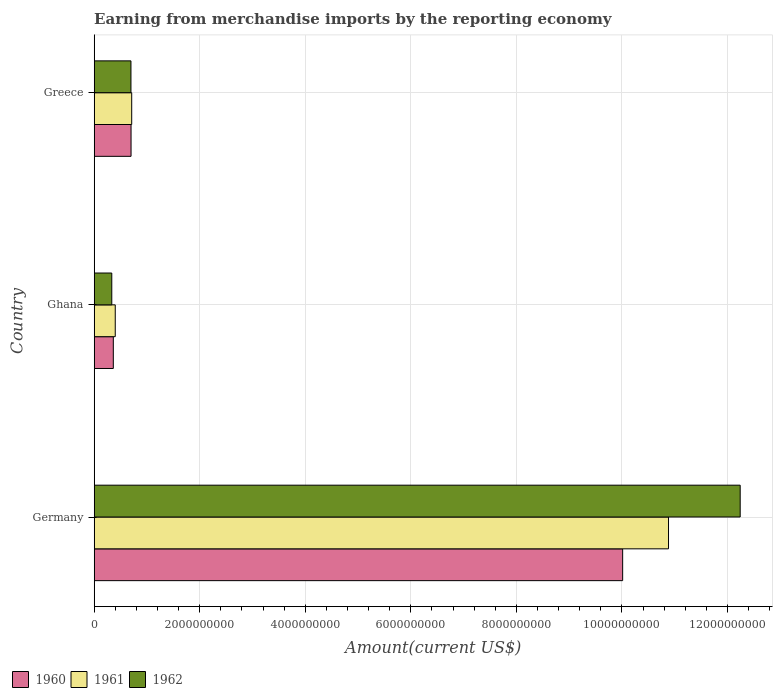How many different coloured bars are there?
Provide a succinct answer. 3. How many groups of bars are there?
Offer a very short reply. 3. Are the number of bars per tick equal to the number of legend labels?
Your answer should be compact. Yes. What is the label of the 1st group of bars from the top?
Ensure brevity in your answer.  Greece. In how many cases, is the number of bars for a given country not equal to the number of legend labels?
Provide a succinct answer. 0. What is the amount earned from merchandise imports in 1962 in Greece?
Give a very brief answer. 6.96e+08. Across all countries, what is the maximum amount earned from merchandise imports in 1960?
Make the answer very short. 1.00e+1. Across all countries, what is the minimum amount earned from merchandise imports in 1962?
Your response must be concise. 3.33e+08. In which country was the amount earned from merchandise imports in 1962 maximum?
Your answer should be very brief. Germany. What is the total amount earned from merchandise imports in 1962 in the graph?
Keep it short and to the point. 1.33e+1. What is the difference between the amount earned from merchandise imports in 1961 in Germany and that in Ghana?
Offer a very short reply. 1.05e+1. What is the difference between the amount earned from merchandise imports in 1960 in Greece and the amount earned from merchandise imports in 1962 in Ghana?
Ensure brevity in your answer.  3.65e+08. What is the average amount earned from merchandise imports in 1961 per country?
Ensure brevity in your answer.  4.00e+09. What is the difference between the amount earned from merchandise imports in 1961 and amount earned from merchandise imports in 1960 in Greece?
Your answer should be very brief. 1.22e+07. What is the ratio of the amount earned from merchandise imports in 1961 in Ghana to that in Greece?
Offer a terse response. 0.56. What is the difference between the highest and the second highest amount earned from merchandise imports in 1961?
Give a very brief answer. 1.02e+1. What is the difference between the highest and the lowest amount earned from merchandise imports in 1961?
Give a very brief answer. 1.05e+1. In how many countries, is the amount earned from merchandise imports in 1961 greater than the average amount earned from merchandise imports in 1961 taken over all countries?
Offer a very short reply. 1. Is the sum of the amount earned from merchandise imports in 1961 in Germany and Ghana greater than the maximum amount earned from merchandise imports in 1962 across all countries?
Your answer should be compact. No. What does the 3rd bar from the top in Germany represents?
Offer a terse response. 1960. What does the 3rd bar from the bottom in Greece represents?
Make the answer very short. 1962. Is it the case that in every country, the sum of the amount earned from merchandise imports in 1960 and amount earned from merchandise imports in 1962 is greater than the amount earned from merchandise imports in 1961?
Ensure brevity in your answer.  Yes. How many bars are there?
Provide a short and direct response. 9. Are all the bars in the graph horizontal?
Keep it short and to the point. Yes. How many countries are there in the graph?
Ensure brevity in your answer.  3. Does the graph contain any zero values?
Provide a succinct answer. No. Does the graph contain grids?
Give a very brief answer. Yes. How many legend labels are there?
Make the answer very short. 3. How are the legend labels stacked?
Offer a terse response. Horizontal. What is the title of the graph?
Offer a very short reply. Earning from merchandise imports by the reporting economy. Does "1981" appear as one of the legend labels in the graph?
Give a very brief answer. No. What is the label or title of the X-axis?
Provide a short and direct response. Amount(current US$). What is the label or title of the Y-axis?
Ensure brevity in your answer.  Country. What is the Amount(current US$) in 1960 in Germany?
Provide a succinct answer. 1.00e+1. What is the Amount(current US$) in 1961 in Germany?
Provide a short and direct response. 1.09e+1. What is the Amount(current US$) of 1962 in Germany?
Your answer should be very brief. 1.22e+1. What is the Amount(current US$) of 1960 in Ghana?
Your answer should be very brief. 3.62e+08. What is the Amount(current US$) in 1961 in Ghana?
Provide a succinct answer. 3.99e+08. What is the Amount(current US$) of 1962 in Ghana?
Make the answer very short. 3.33e+08. What is the Amount(current US$) in 1960 in Greece?
Your answer should be very brief. 6.98e+08. What is the Amount(current US$) of 1961 in Greece?
Offer a terse response. 7.10e+08. What is the Amount(current US$) of 1962 in Greece?
Provide a succinct answer. 6.96e+08. Across all countries, what is the maximum Amount(current US$) in 1960?
Ensure brevity in your answer.  1.00e+1. Across all countries, what is the maximum Amount(current US$) of 1961?
Give a very brief answer. 1.09e+1. Across all countries, what is the maximum Amount(current US$) in 1962?
Your answer should be compact. 1.22e+1. Across all countries, what is the minimum Amount(current US$) of 1960?
Offer a very short reply. 3.62e+08. Across all countries, what is the minimum Amount(current US$) of 1961?
Offer a very short reply. 3.99e+08. Across all countries, what is the minimum Amount(current US$) in 1962?
Your answer should be compact. 3.33e+08. What is the total Amount(current US$) of 1960 in the graph?
Provide a short and direct response. 1.11e+1. What is the total Amount(current US$) of 1961 in the graph?
Ensure brevity in your answer.  1.20e+1. What is the total Amount(current US$) in 1962 in the graph?
Make the answer very short. 1.33e+1. What is the difference between the Amount(current US$) in 1960 in Germany and that in Ghana?
Your response must be concise. 9.65e+09. What is the difference between the Amount(current US$) in 1961 in Germany and that in Ghana?
Ensure brevity in your answer.  1.05e+1. What is the difference between the Amount(current US$) of 1962 in Germany and that in Ghana?
Provide a short and direct response. 1.19e+1. What is the difference between the Amount(current US$) of 1960 in Germany and that in Greece?
Offer a terse response. 9.31e+09. What is the difference between the Amount(current US$) of 1961 in Germany and that in Greece?
Keep it short and to the point. 1.02e+1. What is the difference between the Amount(current US$) in 1962 in Germany and that in Greece?
Give a very brief answer. 1.15e+1. What is the difference between the Amount(current US$) in 1960 in Ghana and that in Greece?
Make the answer very short. -3.36e+08. What is the difference between the Amount(current US$) of 1961 in Ghana and that in Greece?
Your answer should be compact. -3.12e+08. What is the difference between the Amount(current US$) in 1962 in Ghana and that in Greece?
Give a very brief answer. -3.63e+08. What is the difference between the Amount(current US$) in 1960 in Germany and the Amount(current US$) in 1961 in Ghana?
Keep it short and to the point. 9.61e+09. What is the difference between the Amount(current US$) of 1960 in Germany and the Amount(current US$) of 1962 in Ghana?
Ensure brevity in your answer.  9.68e+09. What is the difference between the Amount(current US$) in 1961 in Germany and the Amount(current US$) in 1962 in Ghana?
Offer a very short reply. 1.05e+1. What is the difference between the Amount(current US$) of 1960 in Germany and the Amount(current US$) of 1961 in Greece?
Ensure brevity in your answer.  9.30e+09. What is the difference between the Amount(current US$) in 1960 in Germany and the Amount(current US$) in 1962 in Greece?
Provide a short and direct response. 9.32e+09. What is the difference between the Amount(current US$) in 1961 in Germany and the Amount(current US$) in 1962 in Greece?
Provide a short and direct response. 1.02e+1. What is the difference between the Amount(current US$) of 1960 in Ghana and the Amount(current US$) of 1961 in Greece?
Offer a terse response. -3.48e+08. What is the difference between the Amount(current US$) in 1960 in Ghana and the Amount(current US$) in 1962 in Greece?
Keep it short and to the point. -3.34e+08. What is the difference between the Amount(current US$) in 1961 in Ghana and the Amount(current US$) in 1962 in Greece?
Give a very brief answer. -2.98e+08. What is the average Amount(current US$) in 1960 per country?
Give a very brief answer. 3.69e+09. What is the average Amount(current US$) in 1961 per country?
Offer a very short reply. 4.00e+09. What is the average Amount(current US$) in 1962 per country?
Make the answer very short. 4.42e+09. What is the difference between the Amount(current US$) in 1960 and Amount(current US$) in 1961 in Germany?
Provide a short and direct response. -8.69e+08. What is the difference between the Amount(current US$) in 1960 and Amount(current US$) in 1962 in Germany?
Provide a succinct answer. -2.23e+09. What is the difference between the Amount(current US$) in 1961 and Amount(current US$) in 1962 in Germany?
Offer a terse response. -1.36e+09. What is the difference between the Amount(current US$) of 1960 and Amount(current US$) of 1961 in Ghana?
Keep it short and to the point. -3.67e+07. What is the difference between the Amount(current US$) in 1960 and Amount(current US$) in 1962 in Ghana?
Your answer should be very brief. 2.89e+07. What is the difference between the Amount(current US$) of 1961 and Amount(current US$) of 1962 in Ghana?
Offer a terse response. 6.56e+07. What is the difference between the Amount(current US$) of 1960 and Amount(current US$) of 1961 in Greece?
Offer a very short reply. -1.22e+07. What is the difference between the Amount(current US$) in 1960 and Amount(current US$) in 1962 in Greece?
Provide a succinct answer. 1.90e+06. What is the difference between the Amount(current US$) of 1961 and Amount(current US$) of 1962 in Greece?
Provide a succinct answer. 1.41e+07. What is the ratio of the Amount(current US$) of 1960 in Germany to that in Ghana?
Your answer should be very brief. 27.65. What is the ratio of the Amount(current US$) of 1961 in Germany to that in Ghana?
Offer a very short reply. 27.29. What is the ratio of the Amount(current US$) in 1962 in Germany to that in Ghana?
Keep it short and to the point. 36.73. What is the ratio of the Amount(current US$) in 1960 in Germany to that in Greece?
Your answer should be compact. 14.34. What is the ratio of the Amount(current US$) in 1961 in Germany to that in Greece?
Your answer should be very brief. 15.32. What is the ratio of the Amount(current US$) in 1962 in Germany to that in Greece?
Give a very brief answer. 17.58. What is the ratio of the Amount(current US$) of 1960 in Ghana to that in Greece?
Your response must be concise. 0.52. What is the ratio of the Amount(current US$) in 1961 in Ghana to that in Greece?
Offer a very short reply. 0.56. What is the ratio of the Amount(current US$) in 1962 in Ghana to that in Greece?
Give a very brief answer. 0.48. What is the difference between the highest and the second highest Amount(current US$) in 1960?
Your answer should be compact. 9.31e+09. What is the difference between the highest and the second highest Amount(current US$) of 1961?
Your response must be concise. 1.02e+1. What is the difference between the highest and the second highest Amount(current US$) of 1962?
Make the answer very short. 1.15e+1. What is the difference between the highest and the lowest Amount(current US$) in 1960?
Your answer should be compact. 9.65e+09. What is the difference between the highest and the lowest Amount(current US$) in 1961?
Give a very brief answer. 1.05e+1. What is the difference between the highest and the lowest Amount(current US$) in 1962?
Your answer should be very brief. 1.19e+1. 